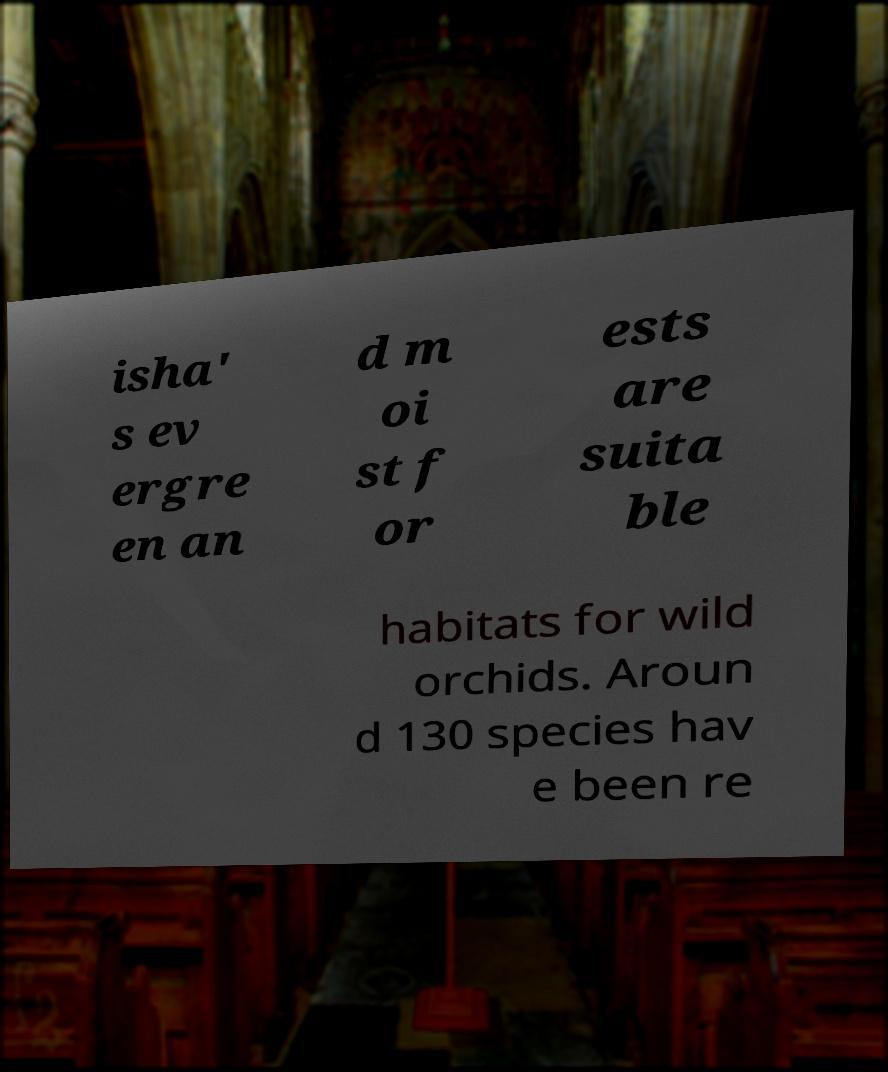Please identify and transcribe the text found in this image. isha' s ev ergre en an d m oi st f or ests are suita ble habitats for wild orchids. Aroun d 130 species hav e been re 